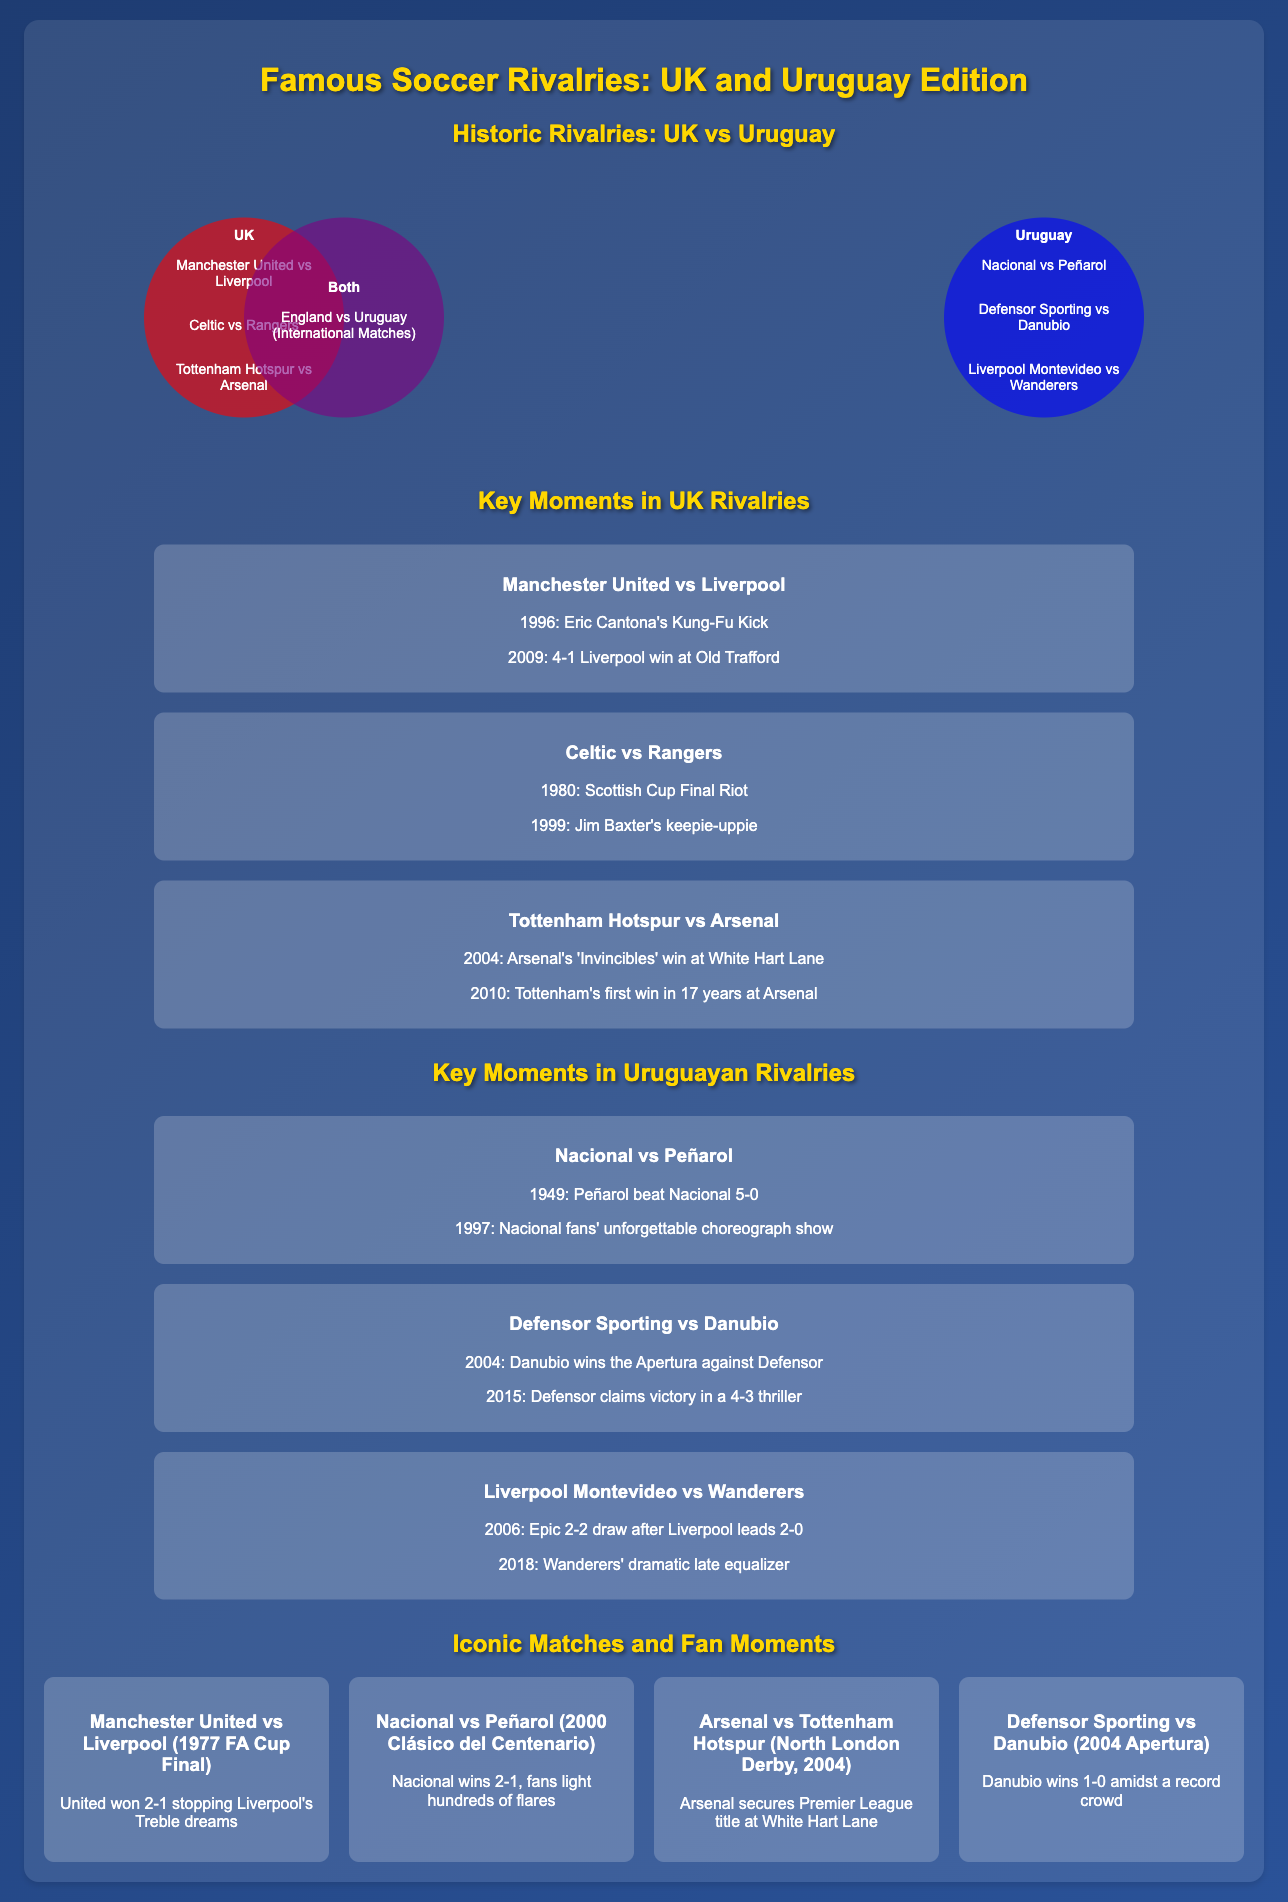what are the three major rivalries listed for the UK? The document lists Manchester United vs Liverpool, Celtic vs Rangers, and Tottenham Hotspur vs Arsenal as major UK rivalries.
Answer: Manchester United vs Liverpool, Celtic vs Rangers, Tottenham Hotspur vs Arsenal what is the iconic match for Nacional vs Peñarol? The document highlights the 2000 Clásico del Centenario as the iconic match for Nacional vs Peñarol.
Answer: 2000 Clásico del Centenario in what year did Eric Cantona perform his famous Kung-Fu kick? The flowchart states that Eric Cantona's Kung-Fu kick occurred in 1996 during the Manchester United vs Liverpool rivalry.
Answer: 1996 how many key moments are listed for the rivalry between Celtic and Rangers? The document details two notable moments in the Celtic vs Rangers rivalry, indicating they had two key moments.
Answer: 2 which team won the 1977 FA Cup Final between Manchester United and Liverpool? The document notes that Manchester United won the 1977 FA Cup Final against Liverpool.
Answer: Manchester United what shared rivalry is mentioned in the both section of the Venn diagram? The Venn diagram indicates that England vs Uruguay in international matches is the notable shared rivalry.
Answer: England vs Uruguay (International Matches) how many iconic matches are listed in the document? The document features four iconic matches in total, including both UK and Uruguayan rivalries.
Answer: 4 which Uruguayan match featured a famous late equalizer in 2018? The document mentions that the match between Liverpool Montevideo vs Wanderers included a dramatic late equalizer in 2018.
Answer: Liverpool Montevideo vs Wanderers 